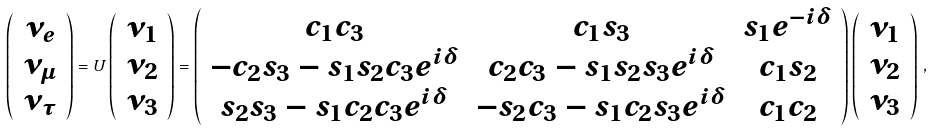Convert formula to latex. <formula><loc_0><loc_0><loc_500><loc_500>\left ( \begin{array} { c } \nu _ { e } \\ \nu _ { \mu } \\ \nu _ { \tau } \end{array} \right ) = U \left ( \begin{array} { c } \nu _ { 1 } \\ \nu _ { 2 } \\ \nu _ { 3 } \end{array} \right ) = \left ( \begin{array} { c c c } c _ { 1 } c _ { 3 } & c _ { 1 } s _ { 3 } & s _ { 1 } e ^ { - i \delta } \\ - c _ { 2 } s _ { 3 } - s _ { 1 } s _ { 2 } c _ { 3 } e ^ { i \delta } & c _ { 2 } c _ { 3 } - s _ { 1 } s _ { 2 } s _ { 3 } e ^ { i \delta } & c _ { 1 } s _ { 2 } \\ s _ { 2 } s _ { 3 } - s _ { 1 } c _ { 2 } c _ { 3 } e ^ { i \delta } & - s _ { 2 } c _ { 3 } - s _ { 1 } c _ { 2 } s _ { 3 } e ^ { i \delta } & c _ { 1 } c _ { 2 } \\ \end{array} \right ) \left ( \begin{array} { c } \nu _ { 1 } \\ \nu _ { 2 } \\ \nu _ { 3 } \end{array} \right ) \, ,</formula> 